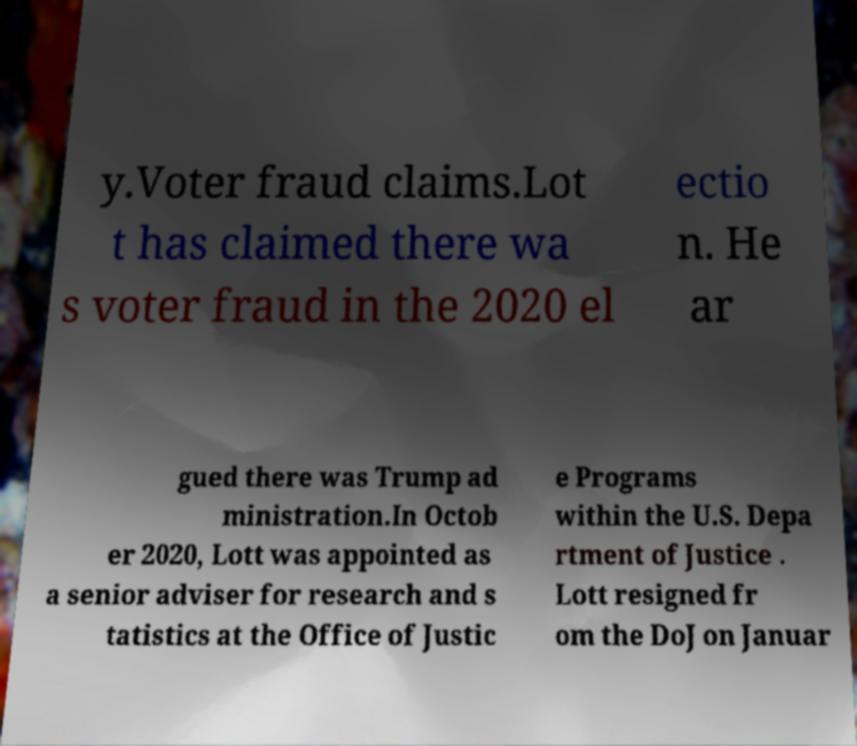Can you accurately transcribe the text from the provided image for me? y.Voter fraud claims.Lot t has claimed there wa s voter fraud in the 2020 el ectio n. He ar gued there was Trump ad ministration.In Octob er 2020, Lott was appointed as a senior adviser for research and s tatistics at the Office of Justic e Programs within the U.S. Depa rtment of Justice . Lott resigned fr om the DoJ on Januar 